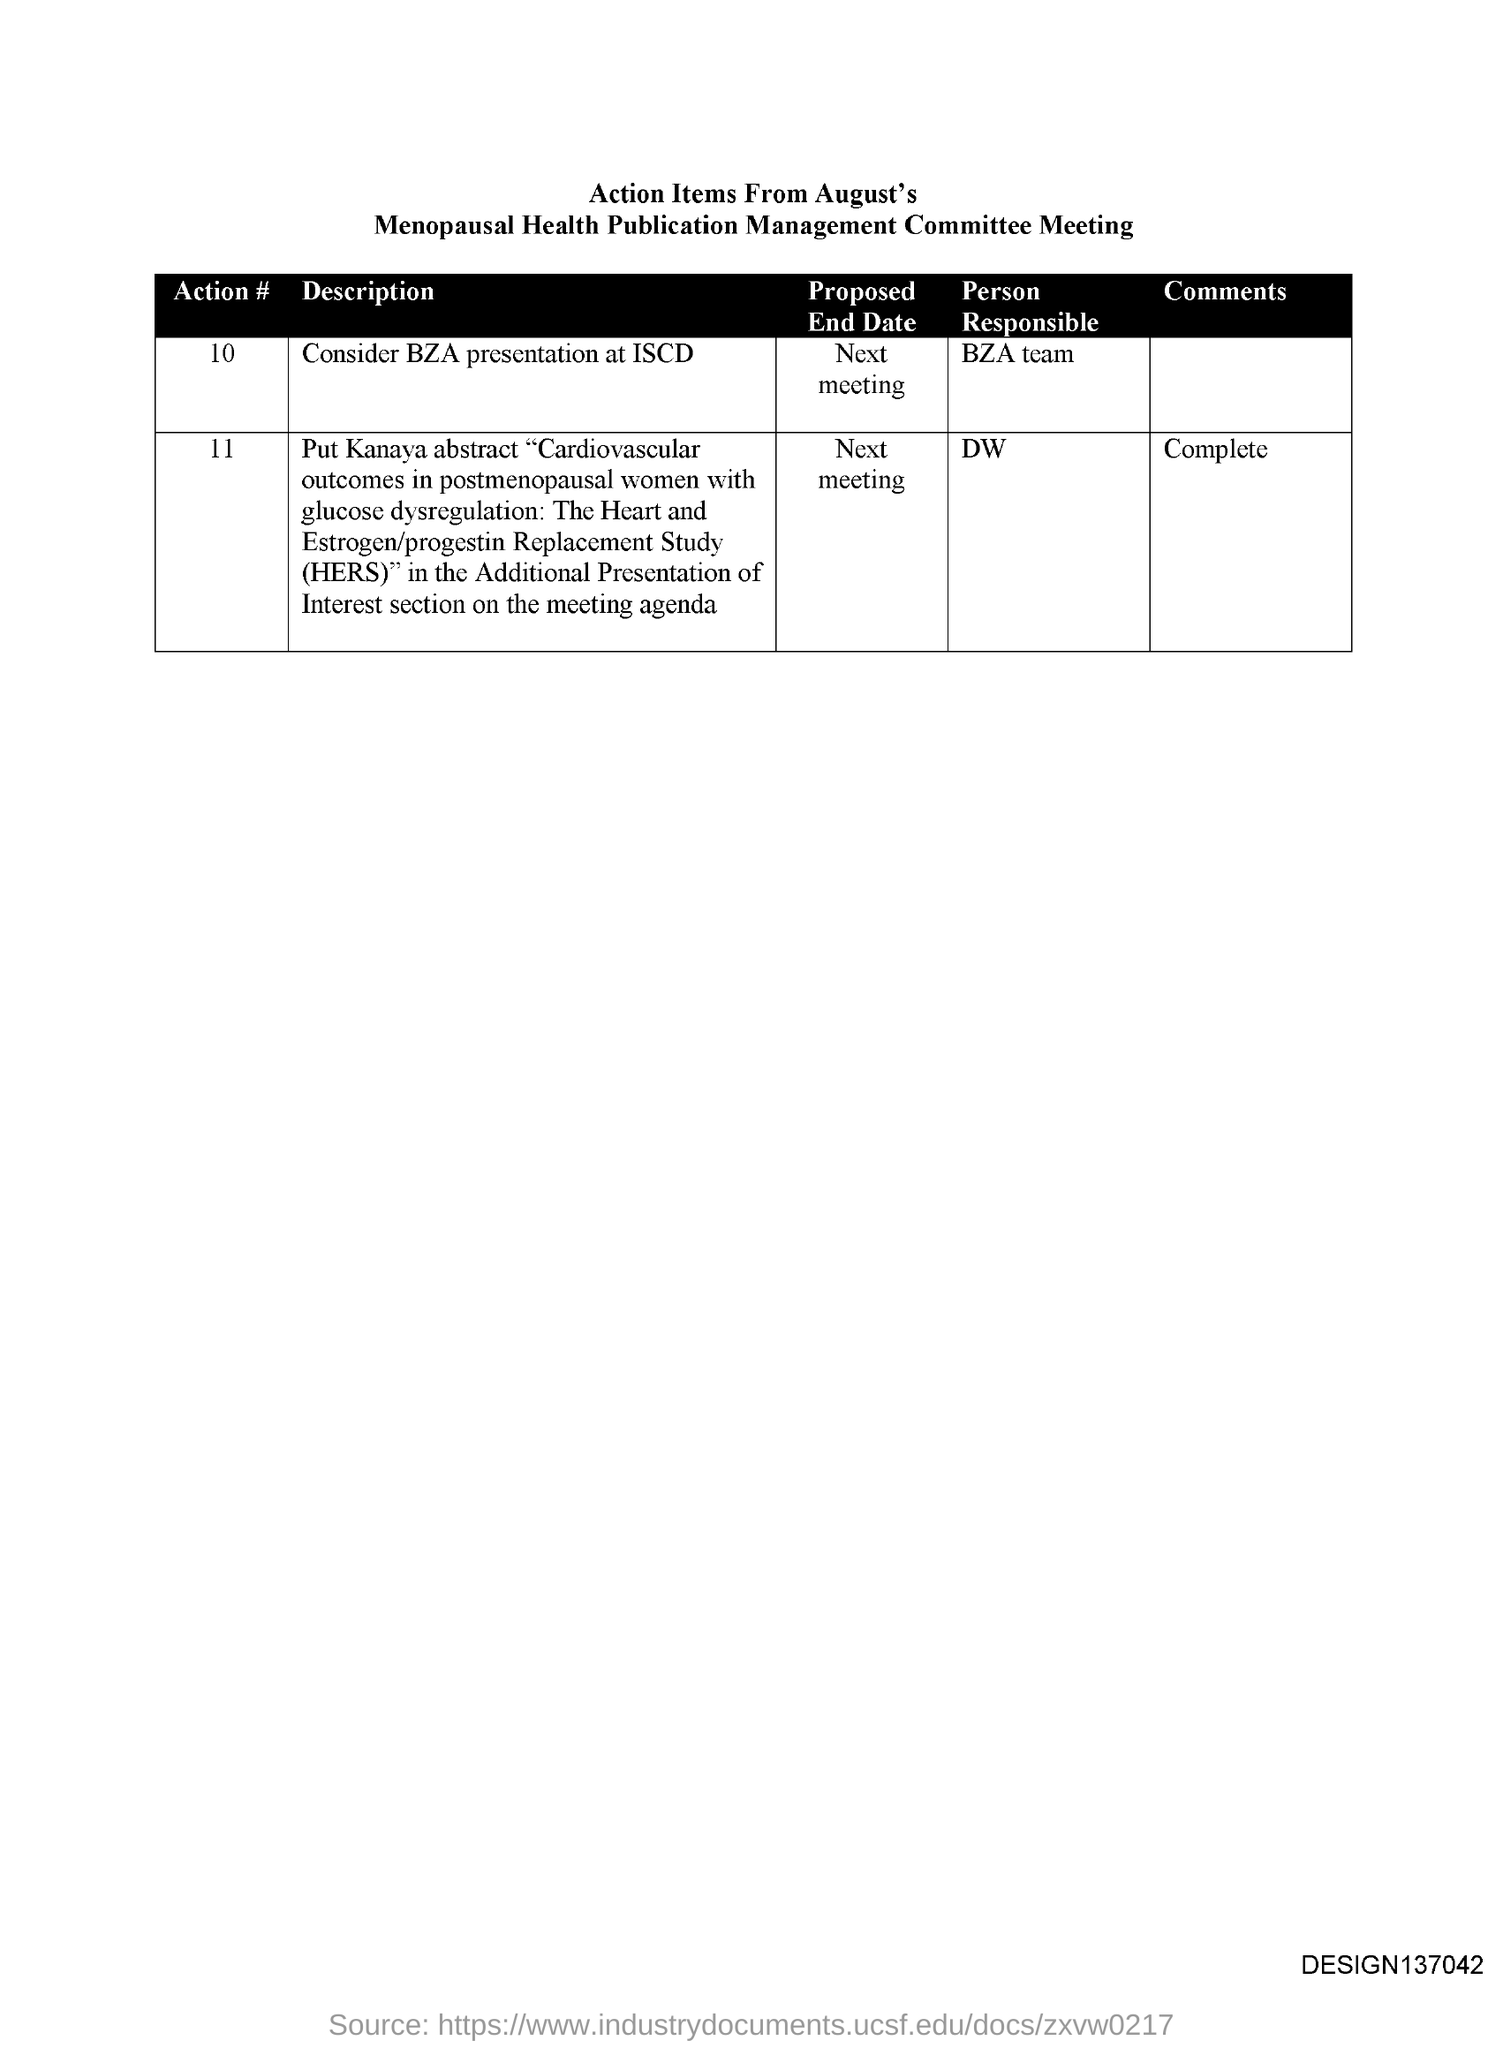Who is the Person Responsible for action # 10?
Offer a terse response. BZA team. Who is the Person Responsible for action # 11?
Offer a terse response. DW. 